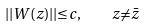Convert formula to latex. <formula><loc_0><loc_0><loc_500><loc_500>| | W ( z ) | | { \leq } c , \quad z { \ne } \bar { z }</formula> 